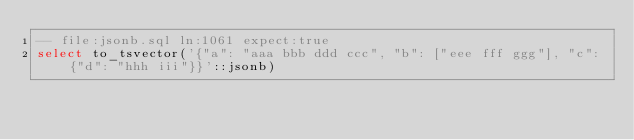Convert code to text. <code><loc_0><loc_0><loc_500><loc_500><_SQL_>-- file:jsonb.sql ln:1061 expect:true
select to_tsvector('{"a": "aaa bbb ddd ccc", "b": ["eee fff ggg"], "c": {"d": "hhh iii"}}'::jsonb)
</code> 